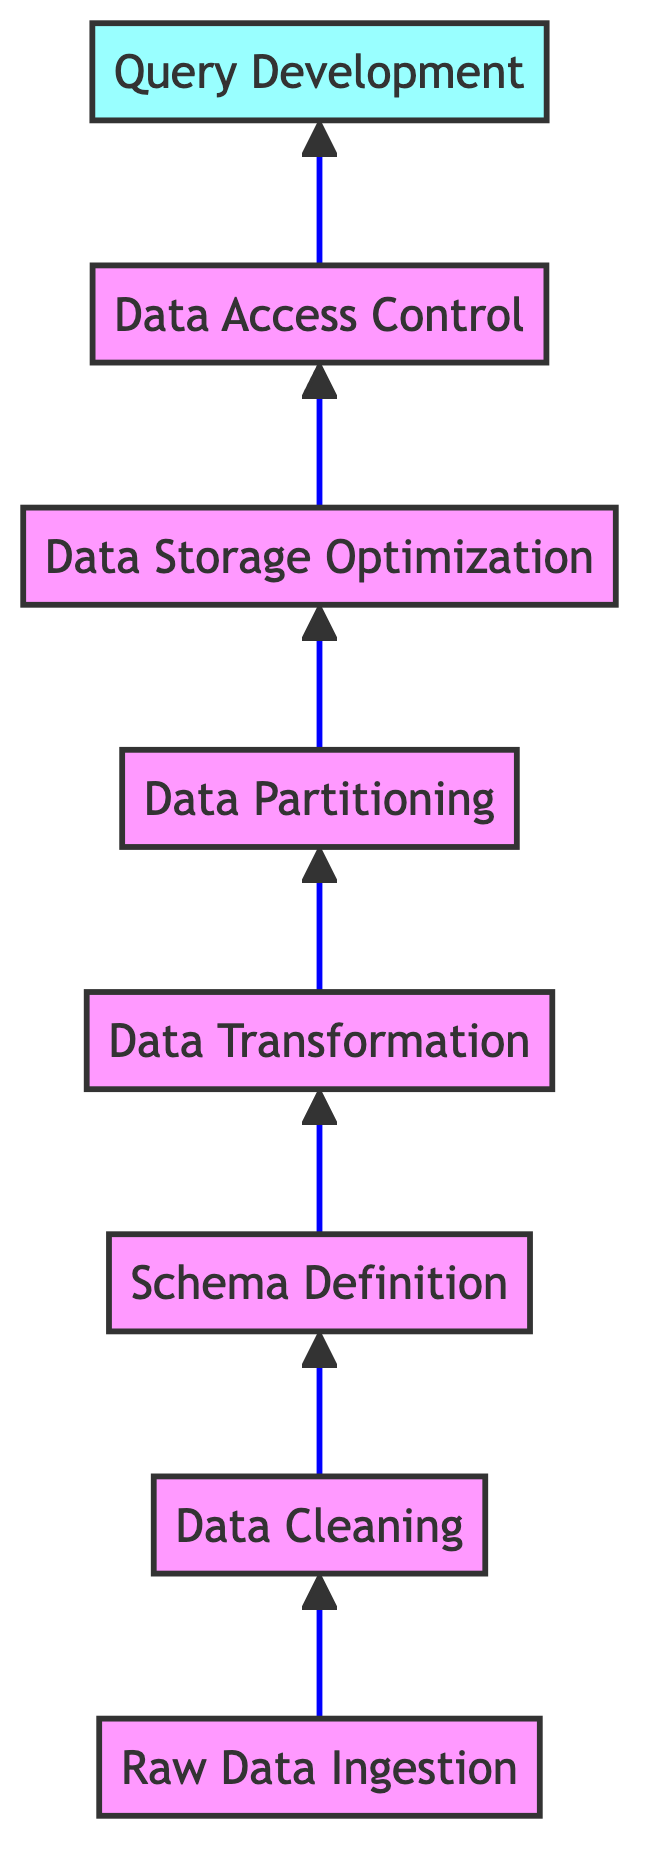What is the first step in the flow chart? The first step, as indicated in the flow chart, is "Raw Data Ingestion," which is the process of importing unprocessed data into HCatalog tables. This can be seen as the starting point before any data processing steps.
Answer: Raw Data Ingestion How many steps are shown in the flow chart? The flow chart has a total of eight steps, listed sequentially from "Raw Data Ingestion" to "Query Development." Each step builds upon the previous one to facilitate the data management process in HCatalog.
Answer: Eight What follows after Data Cleaning in the flow chart? After "Data Cleaning," the next step in the flow chart is "Schema Definition." This means that once data inconsistencies are removed, structured schemas for the HCatalog tables need to be created.
Answer: Schema Definition What is the last step mentioned in the flow chart? The last step is "Query Development," which involves formulating sophisticated SQL queries to extract insights from the structured datasets managed in HCatalog. This is the final process before data insights can be derived.
Answer: Query Development Which step involves defining data types and relationships? The step that involves defining data types and relationships is "Schema Definition." This step is critical to creating a well-structured data environment within HCatalog.
Answer: Schema Definition Which two steps are directly connected after Data Transformation? After "Data Transformation," the two directly connected steps are "Data Partitioning" and "Data Storage Optimization." This means that after transforming the data, it will be organized into segments before optimizing its storage.
Answer: Data Partitioning and Data Storage Optimization What process comes before Data Access Control? The process that comes directly before "Data Access Control" is "Data Storage Optimization." This indicates that the storage of data is optimized prior to implementing any access controls to protect sensitive information.
Answer: Data Storage Optimization How does the flow chart describe the organization of data? The flow chart describes the organization of data during the "Data Partitioning" step, which focuses on organizing data into manageable segments based on defined keys like date or region.
Answer: Data Partitioning 